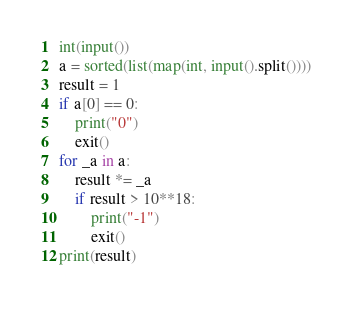Convert code to text. <code><loc_0><loc_0><loc_500><loc_500><_Python_>int(input())
a = sorted(list(map(int, input().split())))
result = 1
if a[0] == 0:
    print("0")
    exit()
for _a in a:
    result *= _a
    if result > 10**18:
        print("-1")
        exit()
print(result)</code> 